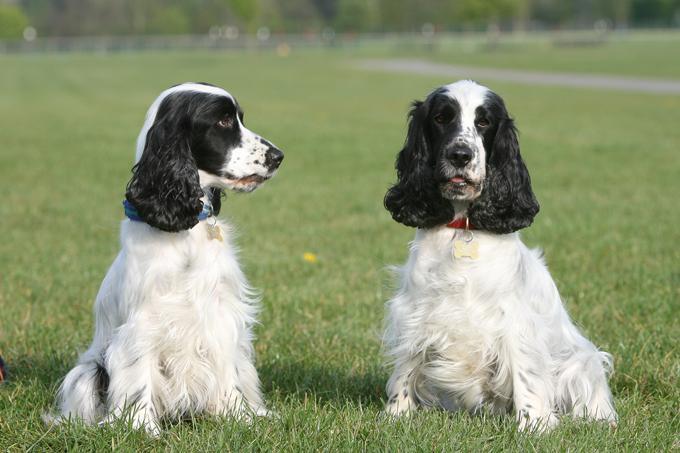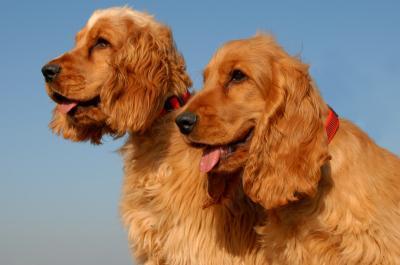The first image is the image on the left, the second image is the image on the right. Examine the images to the left and right. Is the description "One image shows three dogs sitting in a row." accurate? Answer yes or no. No. 